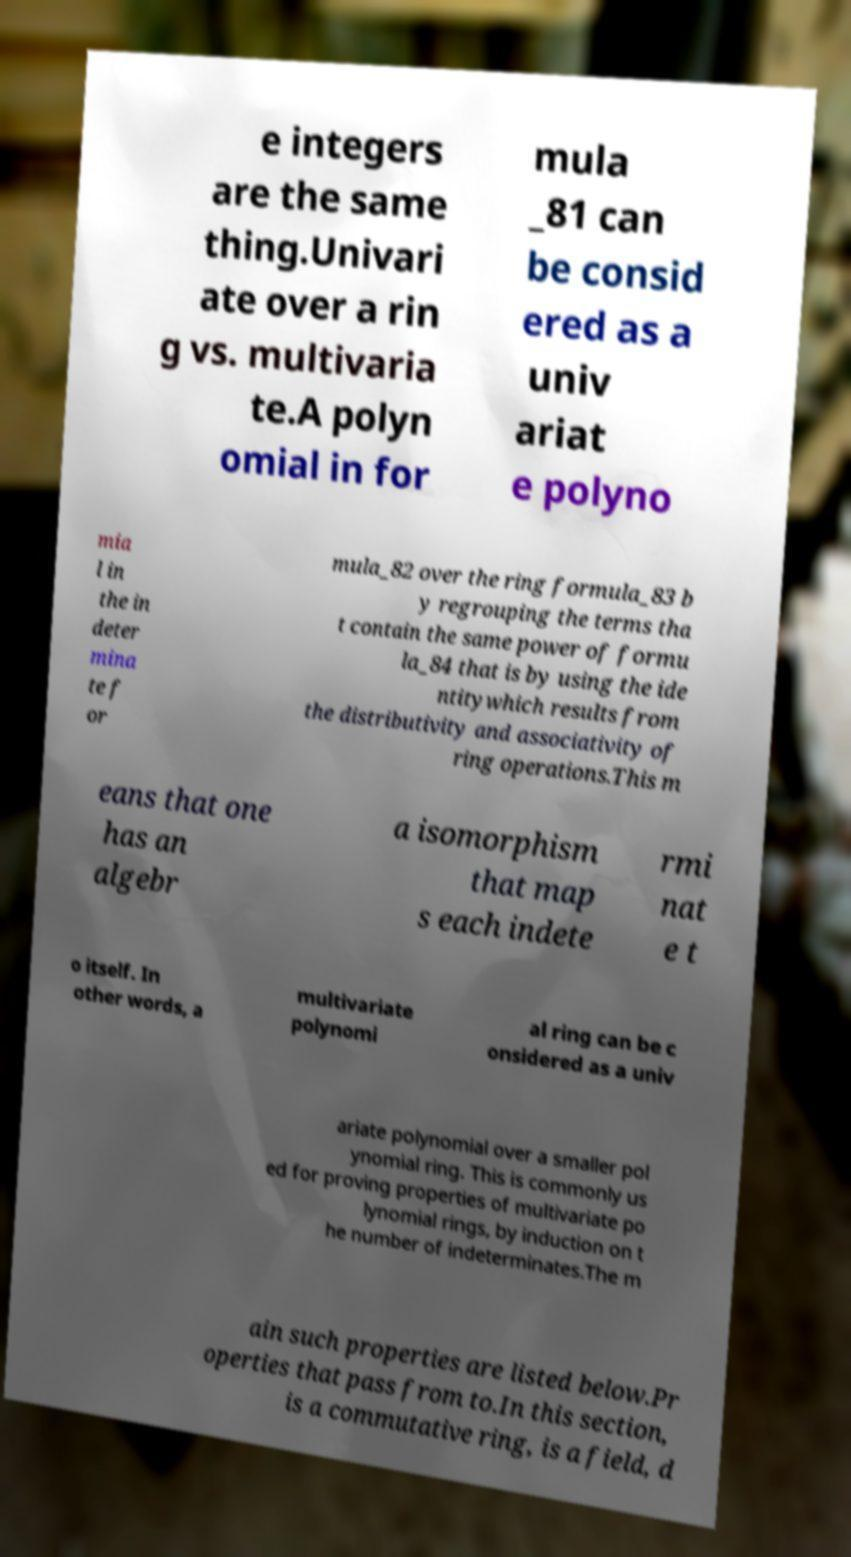For documentation purposes, I need the text within this image transcribed. Could you provide that? e integers are the same thing.Univari ate over a rin g vs. multivaria te.A polyn omial in for mula _81 can be consid ered as a univ ariat e polyno mia l in the in deter mina te f or mula_82 over the ring formula_83 b y regrouping the terms tha t contain the same power of formu la_84 that is by using the ide ntitywhich results from the distributivity and associativity of ring operations.This m eans that one has an algebr a isomorphism that map s each indete rmi nat e t o itself. In other words, a multivariate polynomi al ring can be c onsidered as a univ ariate polynomial over a smaller pol ynomial ring. This is commonly us ed for proving properties of multivariate po lynomial rings, by induction on t he number of indeterminates.The m ain such properties are listed below.Pr operties that pass from to.In this section, is a commutative ring, is a field, d 